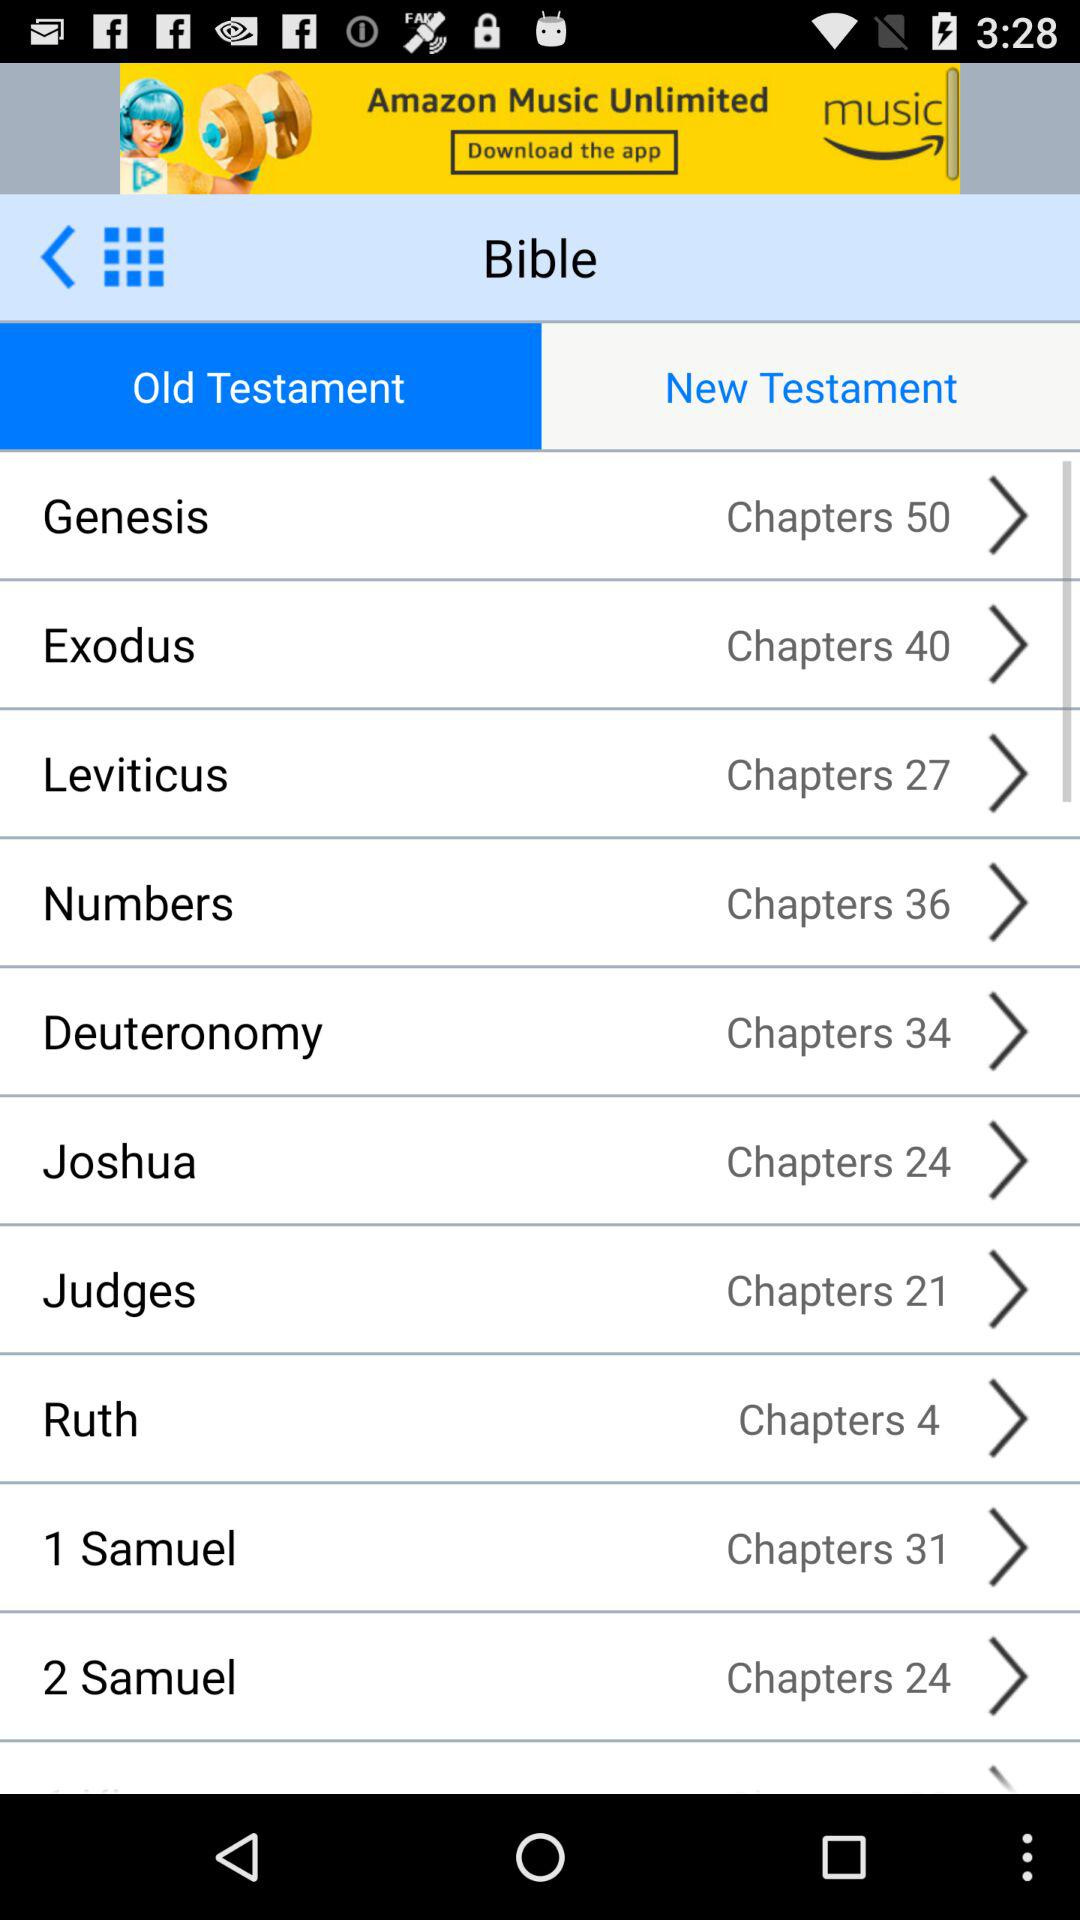How many chapters in total are there in "Ruth"? There are 4 chapters. 